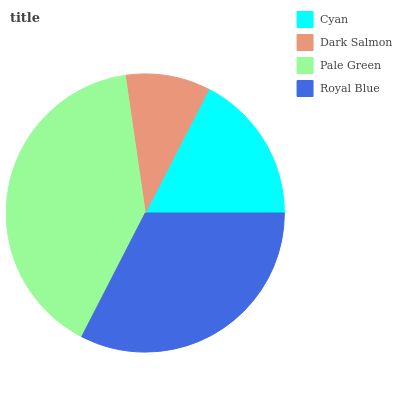Is Dark Salmon the minimum?
Answer yes or no. Yes. Is Pale Green the maximum?
Answer yes or no. Yes. Is Pale Green the minimum?
Answer yes or no. No. Is Dark Salmon the maximum?
Answer yes or no. No. Is Pale Green greater than Dark Salmon?
Answer yes or no. Yes. Is Dark Salmon less than Pale Green?
Answer yes or no. Yes. Is Dark Salmon greater than Pale Green?
Answer yes or no. No. Is Pale Green less than Dark Salmon?
Answer yes or no. No. Is Royal Blue the high median?
Answer yes or no. Yes. Is Cyan the low median?
Answer yes or no. Yes. Is Pale Green the high median?
Answer yes or no. No. Is Dark Salmon the low median?
Answer yes or no. No. 